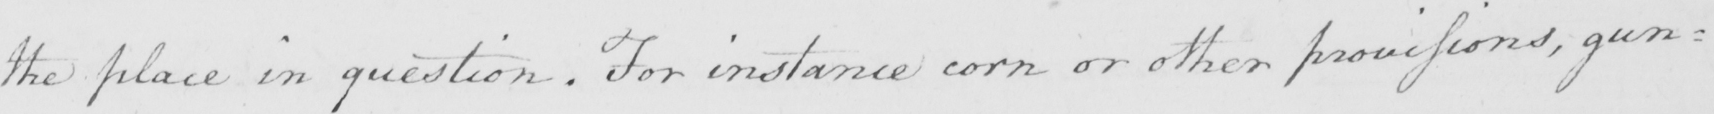What does this handwritten line say? the place in question . For instance corn or other provisions , gun= 